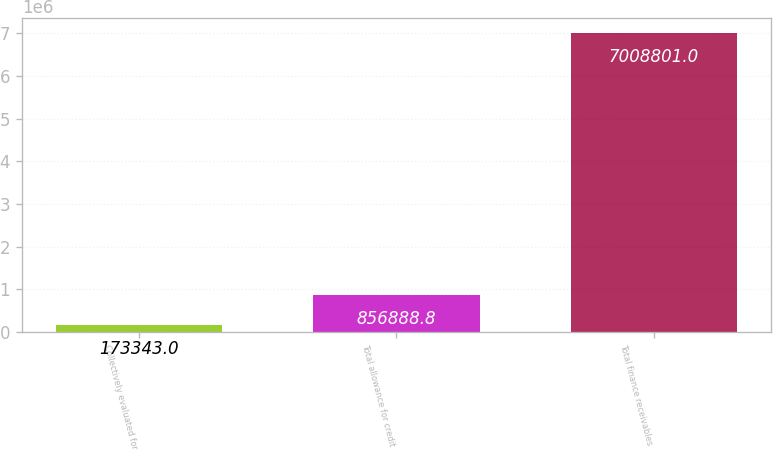Convert chart to OTSL. <chart><loc_0><loc_0><loc_500><loc_500><bar_chart><fcel>Collectively evaluated for<fcel>Total allowance for credit<fcel>Total finance receivables<nl><fcel>173343<fcel>856889<fcel>7.0088e+06<nl></chart> 